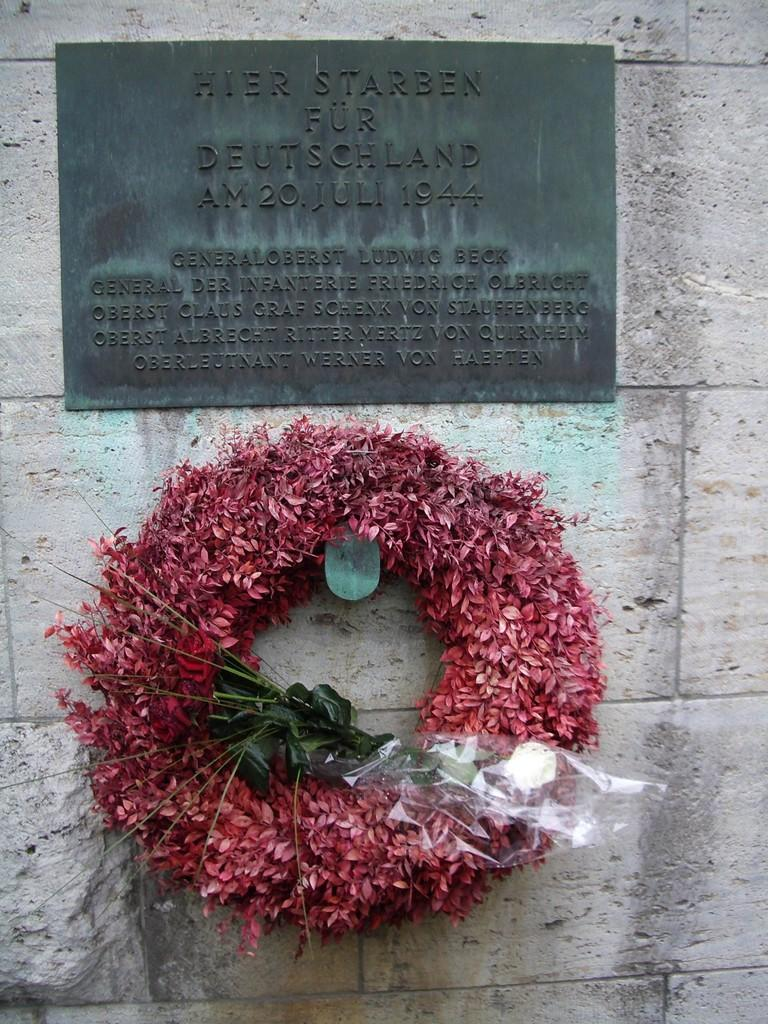What is present on the wall in the image? There is a board and a garland placed on the wall in the image. Can you describe the board on the wall? The board on the wall is a flat surface that can be used for displaying information or decorations. What type of decoration is placed on the wall? There is a garland placed on the wall, which is a string of decorative items, often used for festive occasions. Is there any blood visible on the wall in the image? No, there is no blood visible on the wall in the image. Can you see any clouds in the image? No, there are no clouds visible in the image, as it is focused on the wall and its decorations. 